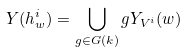Convert formula to latex. <formula><loc_0><loc_0><loc_500><loc_500>Y ( h ^ { i } _ { w } ) = \bigcup _ { g \in G ( k ) } g Y _ { V ^ { i } } ( w )</formula> 